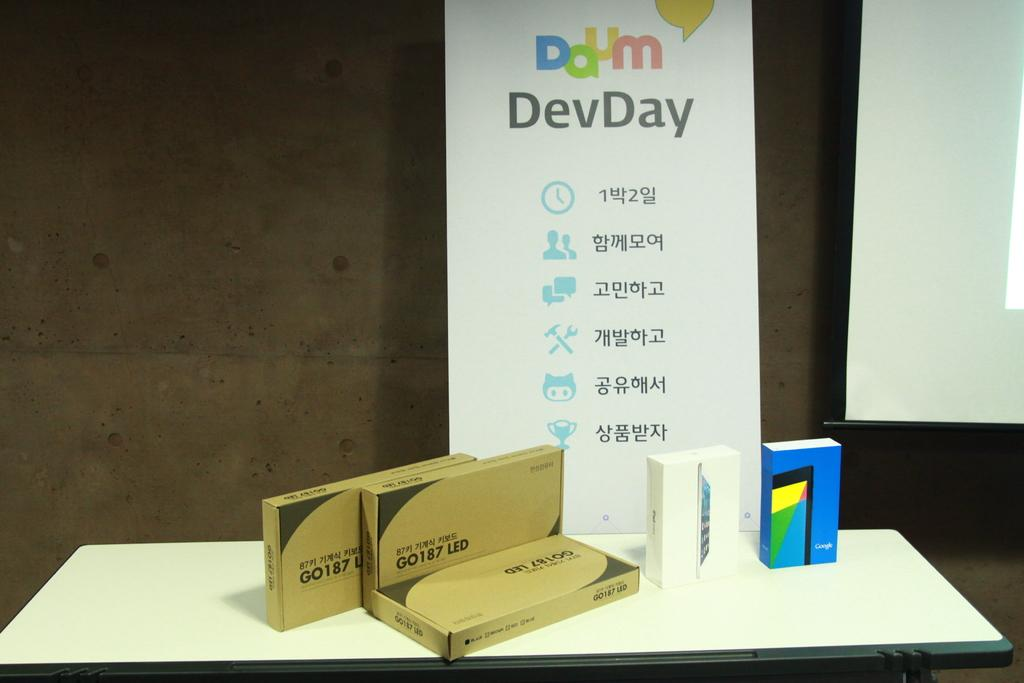<image>
Present a compact description of the photo's key features. A sign for Daum DevDay stands on a table behind boxes of GO 187 LED and a Google phone box. 